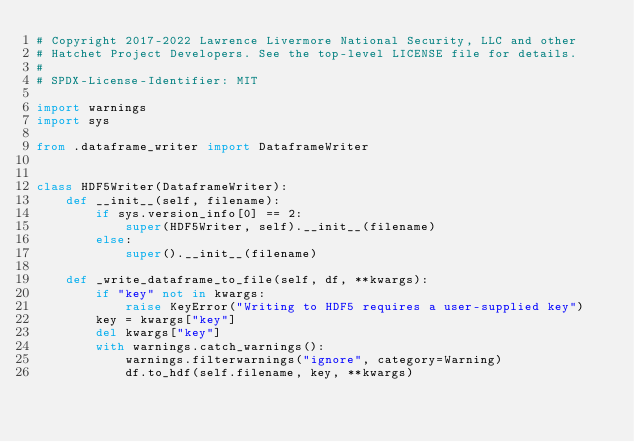<code> <loc_0><loc_0><loc_500><loc_500><_Python_># Copyright 2017-2022 Lawrence Livermore National Security, LLC and other
# Hatchet Project Developers. See the top-level LICENSE file for details.
#
# SPDX-License-Identifier: MIT

import warnings
import sys

from .dataframe_writer import DataframeWriter


class HDF5Writer(DataframeWriter):
    def __init__(self, filename):
        if sys.version_info[0] == 2:
            super(HDF5Writer, self).__init__(filename)
        else:
            super().__init__(filename)

    def _write_dataframe_to_file(self, df, **kwargs):
        if "key" not in kwargs:
            raise KeyError("Writing to HDF5 requires a user-supplied key")
        key = kwargs["key"]
        del kwargs["key"]
        with warnings.catch_warnings():
            warnings.filterwarnings("ignore", category=Warning)
            df.to_hdf(self.filename, key, **kwargs)
</code> 